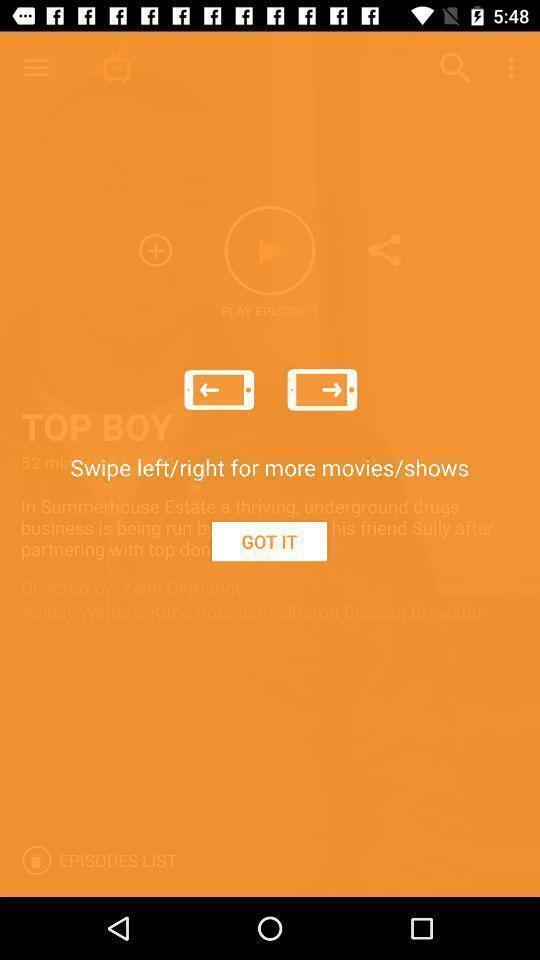Provide a description of this screenshot. Screen displaying demo instructions to access an application. 